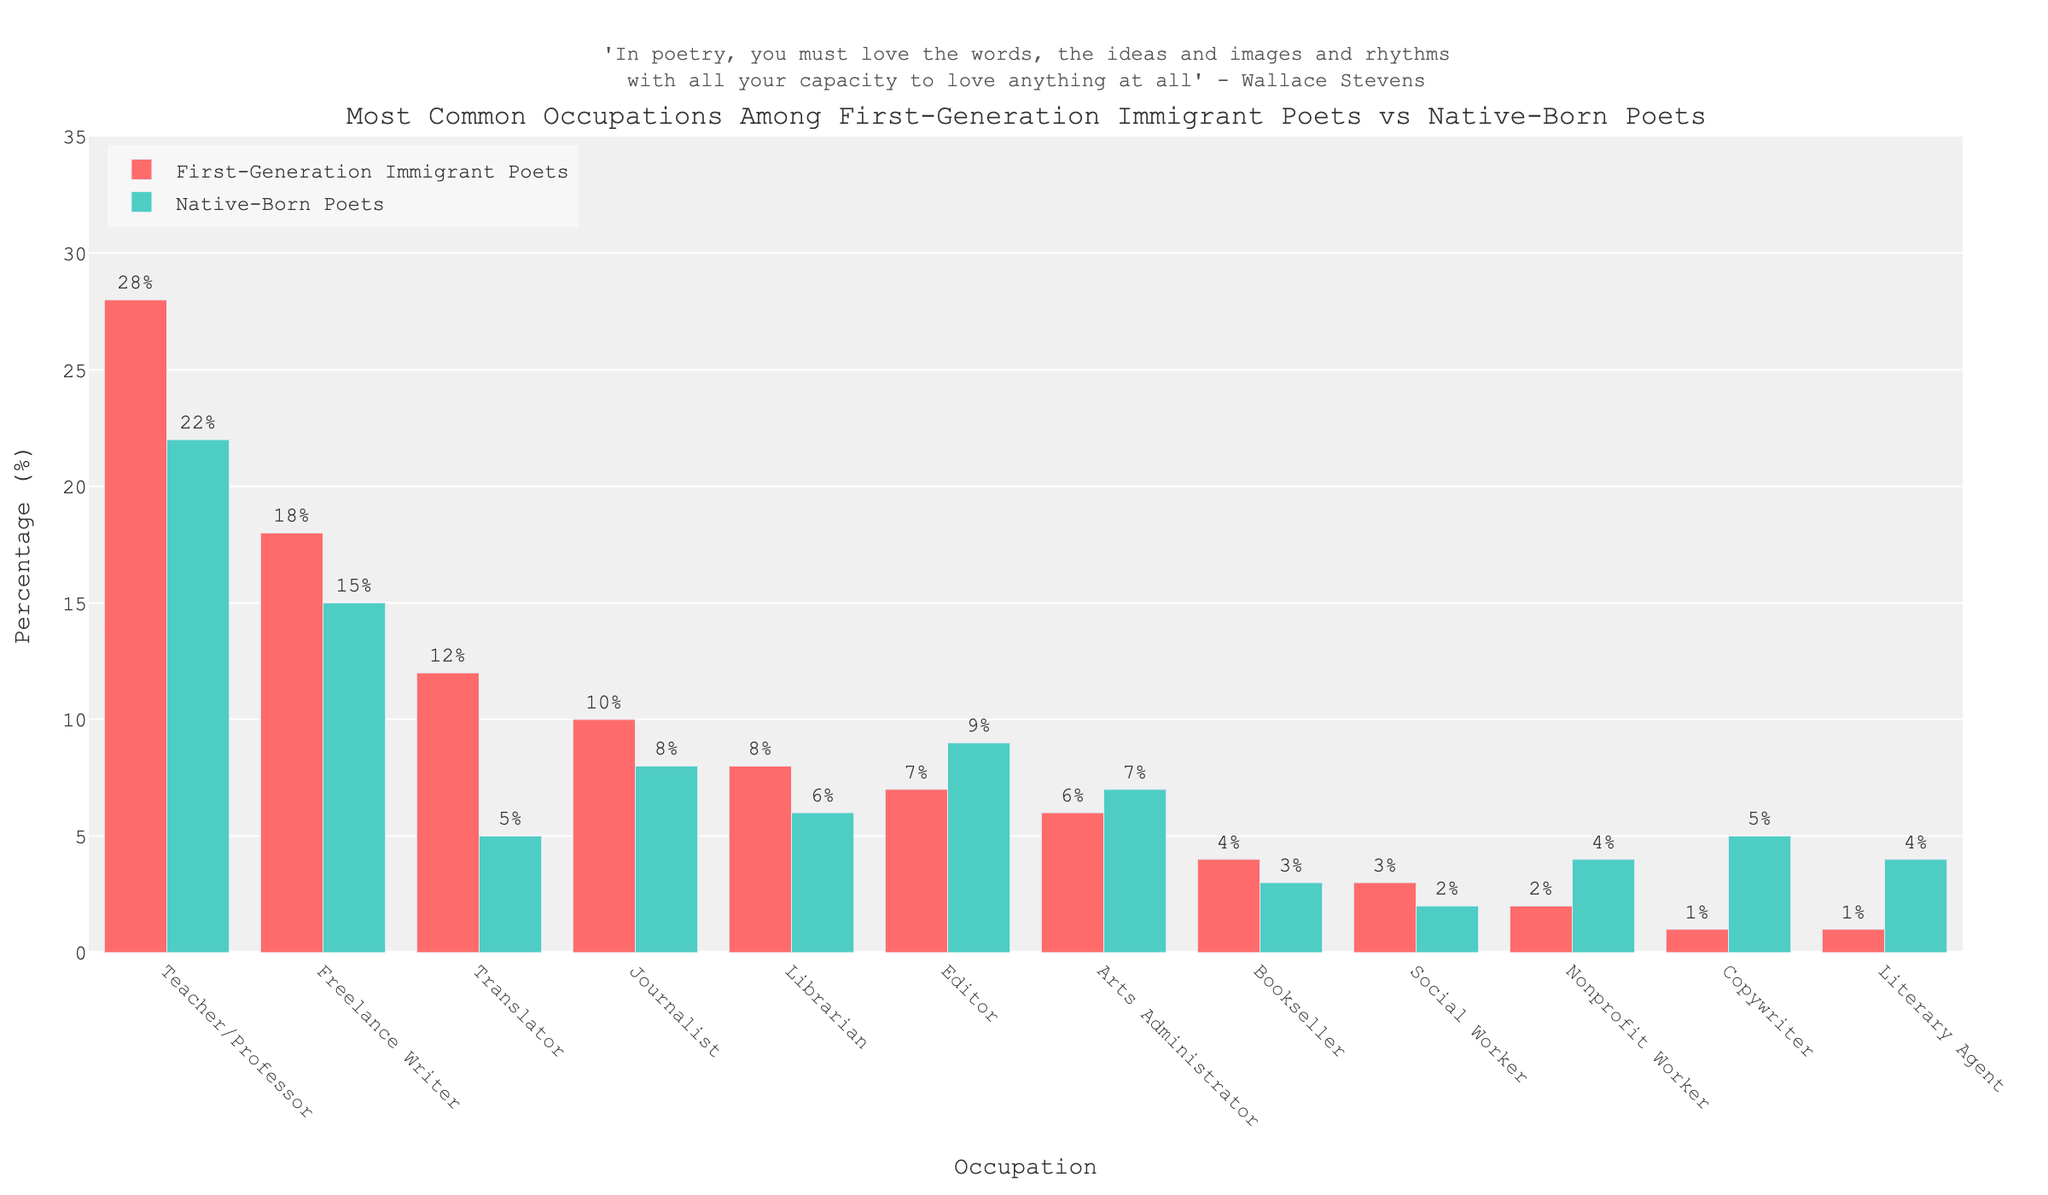Which occupation has the highest percentage among First-Generation Immigrant Poets? The highest bar for First-Generation Immigrant Poets is the one for 'Teacher/Professor' with 28%.
Answer: Teacher/Professor Which occupation has a higher percentage for Native-Born Poets than for First-Generation Immigrant Poets? The bar for 'Copywriter' is higher among Native-Born Poets (5%) compared to First-Generation Immigrant Poets (1%).
Answer: Copywriter What's the difference in percentage between Freelance Writers for First-Generation Immigrant Poets and Native-Born Poets? The percentage for Freelance Writers among First-Generation Immigrant Poets is 18% and for Native-Born Poets is 15%, so the difference is 18 - 15 = 3%.
Answer: 3% Which two occupations have the identical percentages among First-Generation Immigrant Poets? Both 'Copywriter' and 'Literary Agent' have 1% among First-Generation Immigrant Poets.
Answer: Copywriter and Literary Agent Combining the percentages of Translators and Journalists among First-Generation Immigrant Poets, which occupation among Native-Born Poets has the closest percentage to the total? The combined percentage for Translators (12%) and Journalists (10%) among First-Generation Immigrant Poets is 12 + 10 = 22%. The 'Teacher/Professor' among Native-Born Poets has 22%, which is closest.
Answer: Teacher/Professor Which occupation shows the greatest difference in percentage between First-Generation Immigrant Poets and Native-Born Poets favoring the former? Translators show a difference of 12% (First-Generation Immigrant Poets) - 5% (Native-Born Poets) = 7%.
Answer: Translator Which occupation has an equal percentage for both groups? The bar for 'Teacher/Professor' is tall at the same height percentage of 22% for both First-Generation Immigrant Poets and Native-Born Poets.
Answer: Teacher/Professor How many occupations have a higher percentage among First-Generation Immigrant Poets compared to Native-Born Poets? By visually comparing the heights of the bars, 'Teacher/Professor', 'Freelance Writer', 'Translator', 'Journalist', 'Librarian', 'Bookseller', and 'Social Worker' have greater percentages among First-Generation Immigrant Poets than Native-Born Poets. There are 7 such occupations.
Answer: 7 What is the sum of percentages for 'Editor' and 'Arts Administrator' occupations among Native-Born Poets? The percentage for 'Editor' is 9% and for 'Arts Administrator' is 7%, so the sum is 9 + 7 = 16%.
Answer: 16% What is the combined percentage for the 'Teacher/Professor' and 'Translator' occupations among First-Generation Immigrant Poets? The percentage for 'Teacher/Professor' is 28% and for 'Translator' is 12%, so the combined percentage is 28 + 12 = 40%.
Answer: 40% 